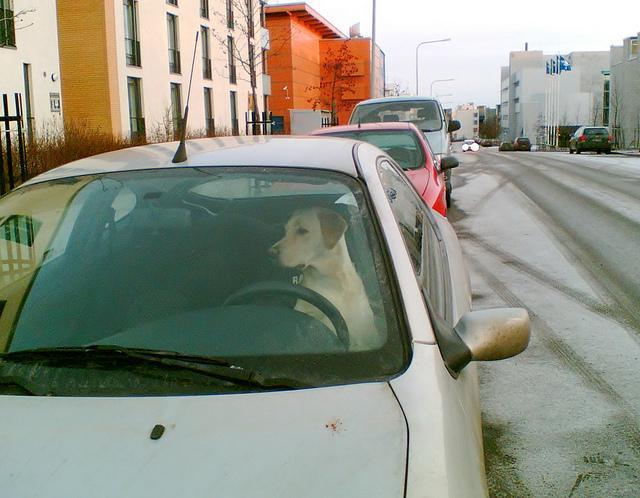How many dogs in the car?
Give a very brief answer. 1. How many cars are in the picture?
Give a very brief answer. 3. 